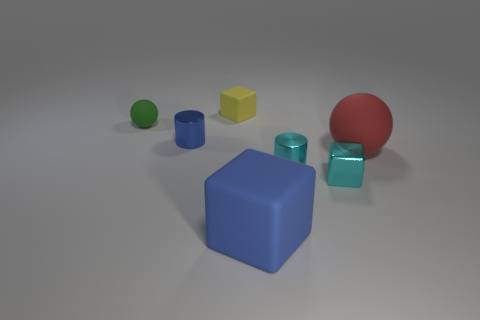What number of other things are there of the same color as the small shiny block?
Ensure brevity in your answer.  1. There is a blue object right of the block behind the matte ball that is on the left side of the big red object; what is its material?
Provide a succinct answer. Rubber. Are there any cylinders that have the same size as the green thing?
Your answer should be compact. Yes. There is a yellow thing that is the same size as the cyan metallic cylinder; what material is it?
Your answer should be compact. Rubber. There is a tiny cyan object left of the tiny cyan metal cube; what shape is it?
Your response must be concise. Cylinder. Is the blue thing on the left side of the tiny yellow object made of the same material as the small cube in front of the tiny rubber sphere?
Your response must be concise. Yes. What number of cyan objects have the same shape as the yellow object?
Offer a very short reply. 1. There is a thing that is the same color as the tiny metal cube; what material is it?
Your answer should be compact. Metal. What number of things are either tiny blue metal cylinders or things that are on the right side of the tiny yellow cube?
Your answer should be compact. 5. What is the material of the green thing?
Your answer should be compact. Rubber. 